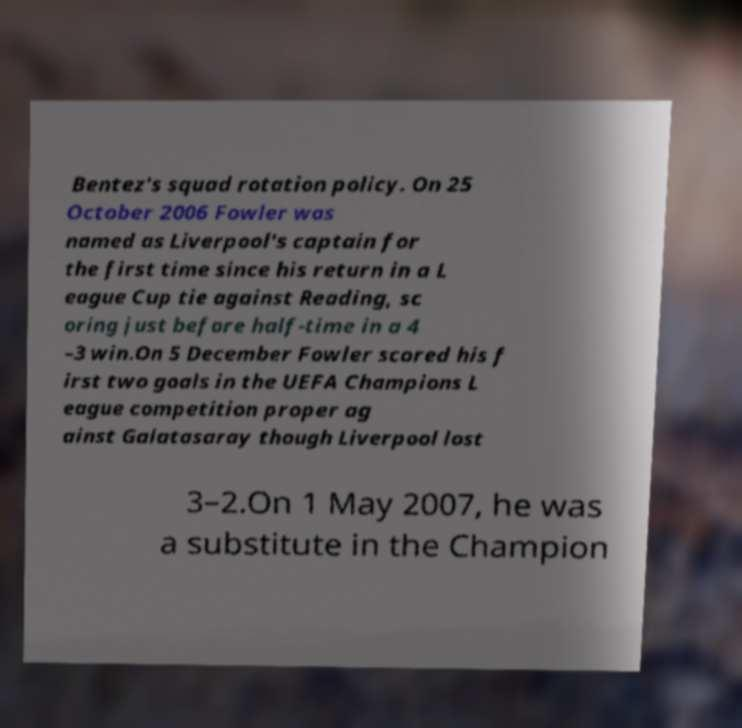There's text embedded in this image that I need extracted. Can you transcribe it verbatim? Bentez's squad rotation policy. On 25 October 2006 Fowler was named as Liverpool's captain for the first time since his return in a L eague Cup tie against Reading, sc oring just before half-time in a 4 –3 win.On 5 December Fowler scored his f irst two goals in the UEFA Champions L eague competition proper ag ainst Galatasaray though Liverpool lost 3–2.On 1 May 2007, he was a substitute in the Champion 